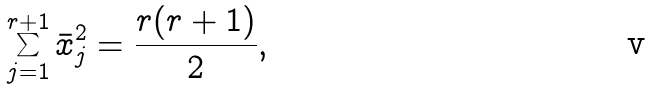<formula> <loc_0><loc_0><loc_500><loc_500>\sum _ { j = 1 } ^ { r + 1 } \bar { x } _ { j } ^ { 2 } = { \frac { r ( r + 1 ) } { 2 } } ,</formula> 